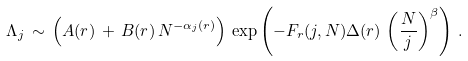<formula> <loc_0><loc_0><loc_500><loc_500>\Lambda _ { j } \, \sim \, \left ( A ( r ) \, + \, B ( r ) \, N ^ { - \alpha _ { j } ( r ) } \right ) \, \exp \left ( - F _ { r } ( j , N ) \Delta ( r ) \, \left ( \frac { N } { j } \right ) ^ { \beta } \right ) \, .</formula> 